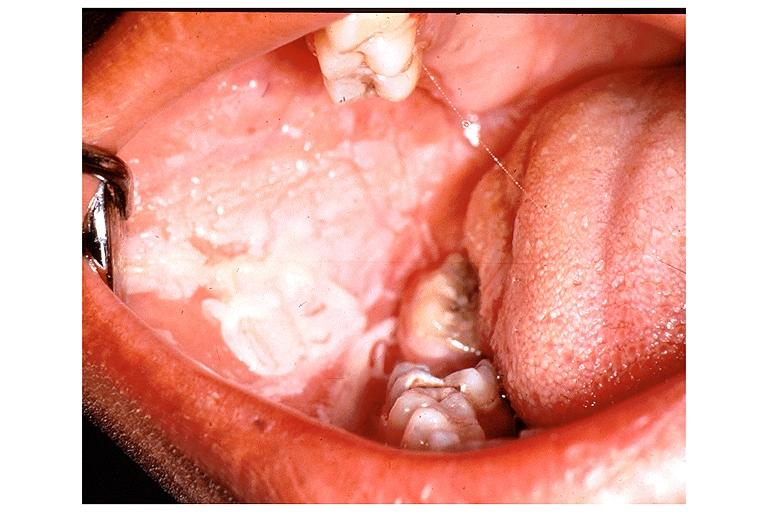do gastrointestinal burn from topical asprin?
Answer the question using a single word or phrase. No 